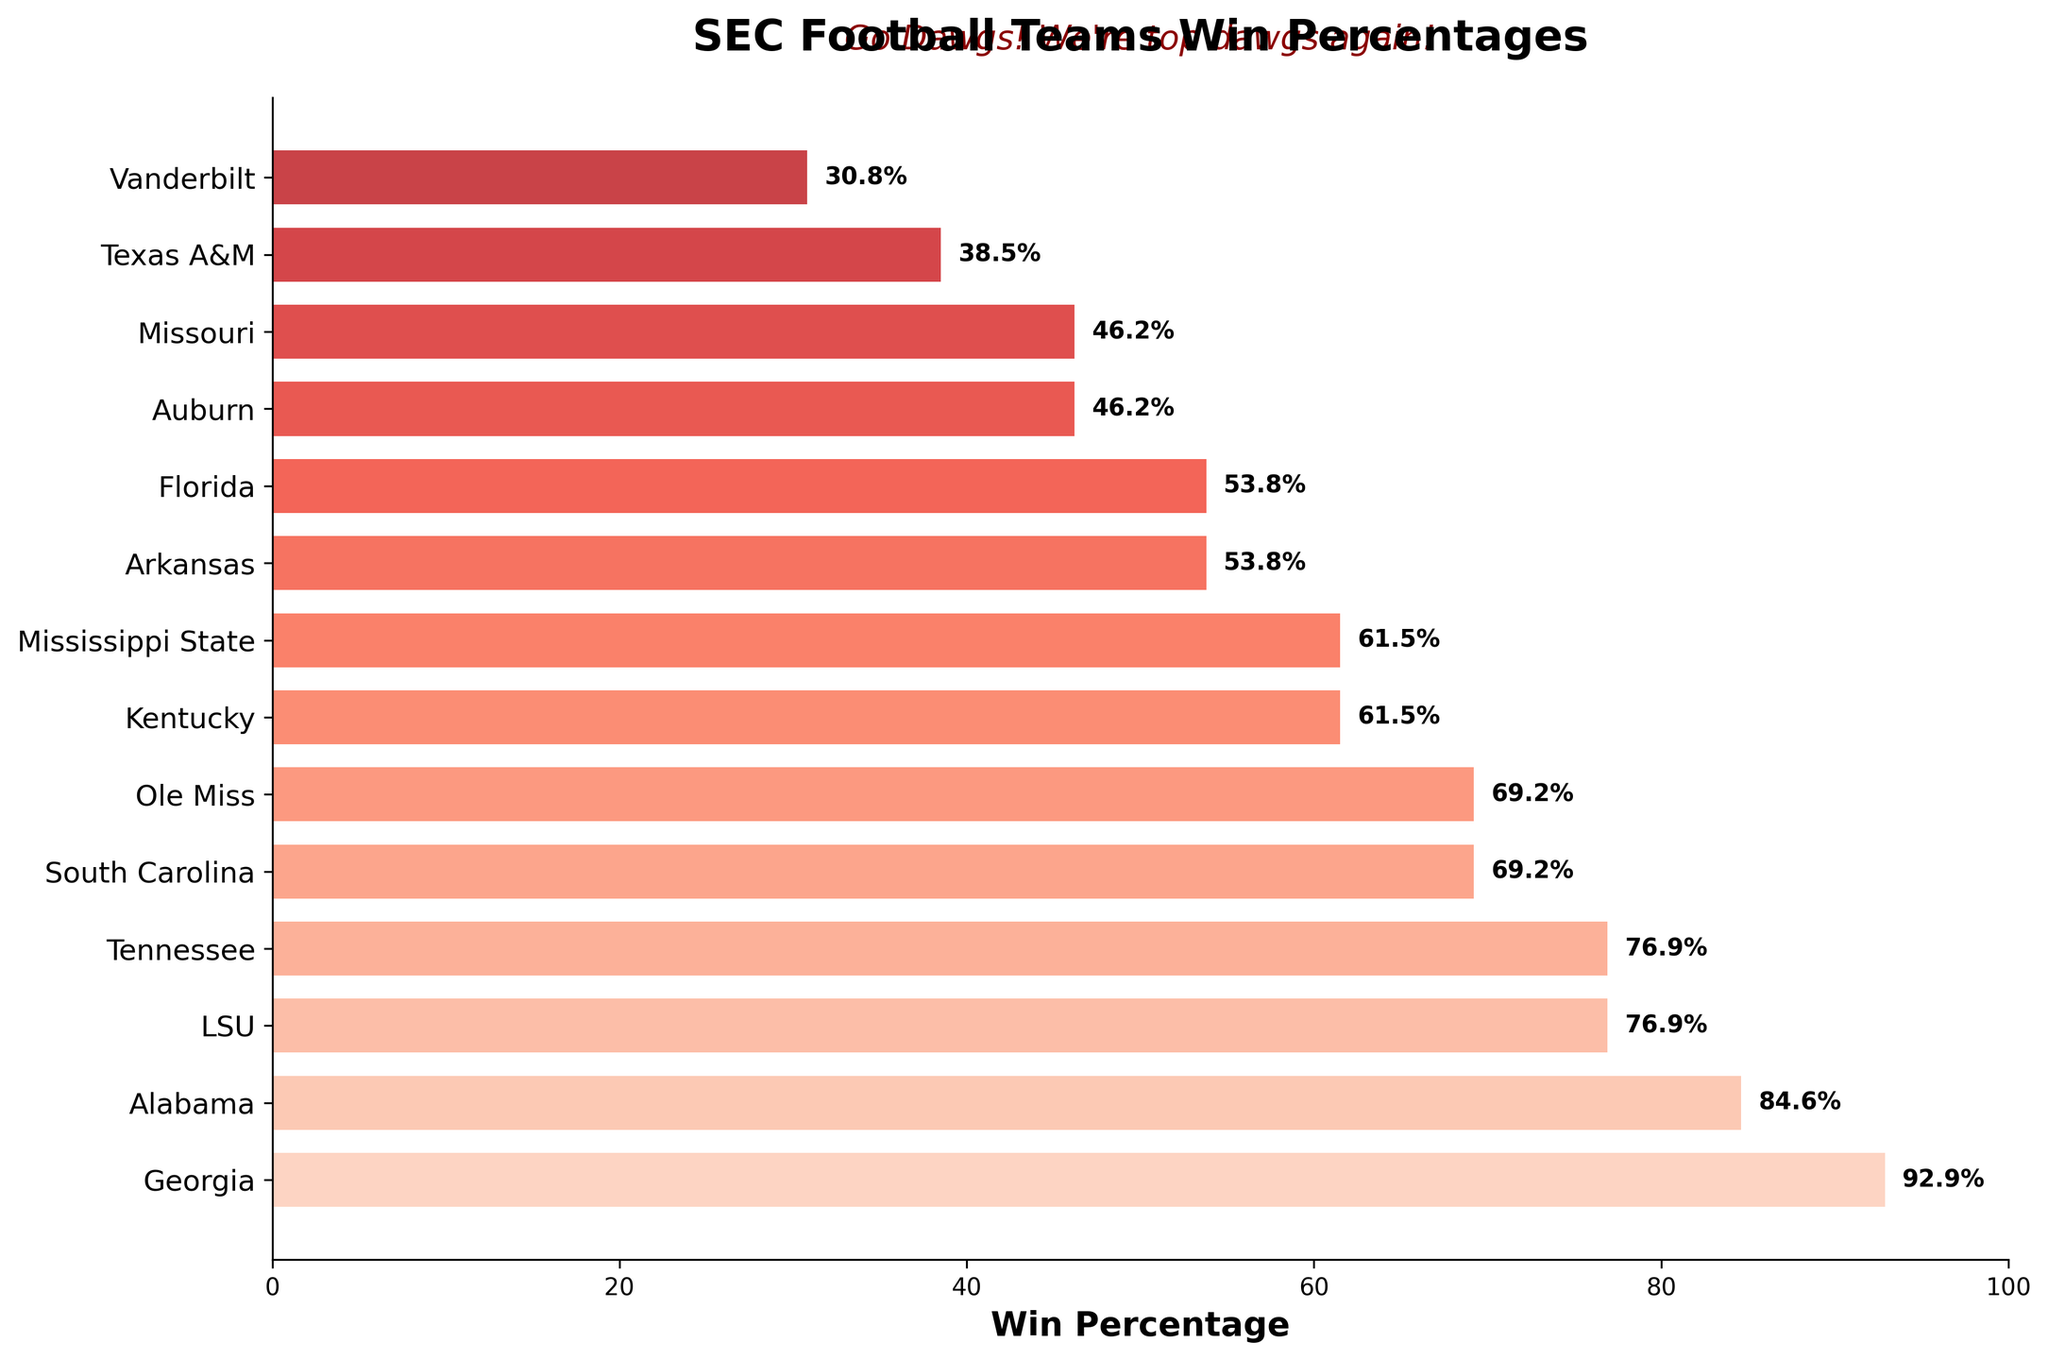What team has the highest win percentage in the SEC football season? The top bar in the funnel chart, representing the Georgia Bulldogs, has the highest win percentage of 92.9.
Answer: Georgia Which teams have a win percentage of 53.8? The chart shows Arkansas and Florida, both with win percentages of 53.8.
Answer: Arkansas and Florida What is the win percentage difference between Texas A&M and Vanderbilt? Texas A&M has a win percentage of 38.5 and Vanderbilt has 30.8, so the difference is 38.5 - 30.8 = 7.7.
Answer: 7.7 How many teams have a win percentage of 69.2? The funnel chart shows South Carolina and Ole Miss with win percentages of 69.2.
Answer: 2 What is the average win percentage of the top 3 teams? The top 3 teams are Georgia (92.9), Alabama (84.6), and LSU (76.9). The average is (92.9 + 84.6 + 76.9) / 3 = 84.8.
Answer: 84.8 How does Tennessee's win percentage compare to South Carolina’s? Tennessee has a win percentage of 76.9 and South Carolina has 69.2. Therefore, Tennessee has a higher win percentage.
Answer: Tennessee is higher Which team is directly above Missouri in win percentage? Auburn is directly above Missouri in the funnel chart, both having a win percentage of 46.2.
Answer: Auburn What is the cumulative win percentage of Ole Miss and Kentucky? Ole Miss has a win percentage of 69.2 and Kentucky has 61.5. The cumulative win percentage is 69.2 + 61.5 = 130.7.
Answer: 130.7 